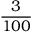<formula> <loc_0><loc_0><loc_500><loc_500>\frac { 3 } { 1 0 0 }</formula> 